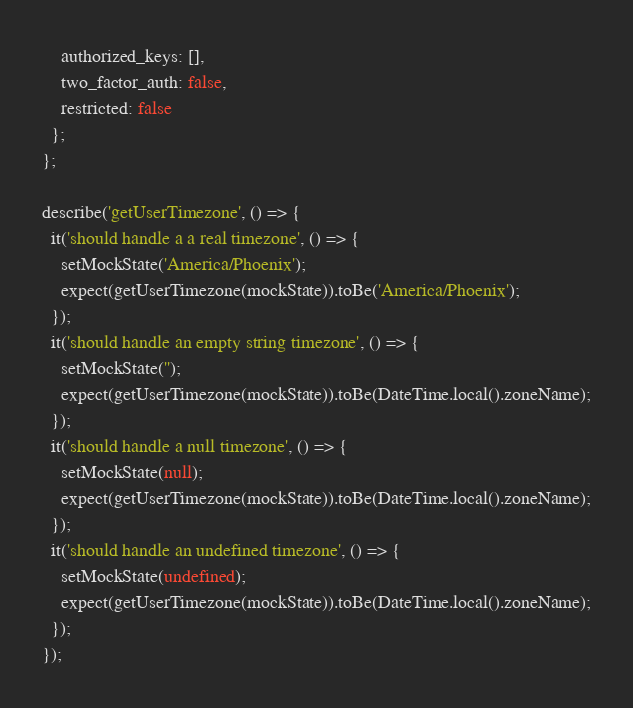<code> <loc_0><loc_0><loc_500><loc_500><_TypeScript_>    authorized_keys: [],
    two_factor_auth: false,
    restricted: false
  };
};

describe('getUserTimezone', () => {
  it('should handle a a real timezone', () => {
    setMockState('America/Phoenix');
    expect(getUserTimezone(mockState)).toBe('America/Phoenix');
  });
  it('should handle an empty string timezone', () => {
    setMockState('');
    expect(getUserTimezone(mockState)).toBe(DateTime.local().zoneName);
  });
  it('should handle a null timezone', () => {
    setMockState(null);
    expect(getUserTimezone(mockState)).toBe(DateTime.local().zoneName);
  });
  it('should handle an undefined timezone', () => {
    setMockState(undefined);
    expect(getUserTimezone(mockState)).toBe(DateTime.local().zoneName);
  });
});
</code> 